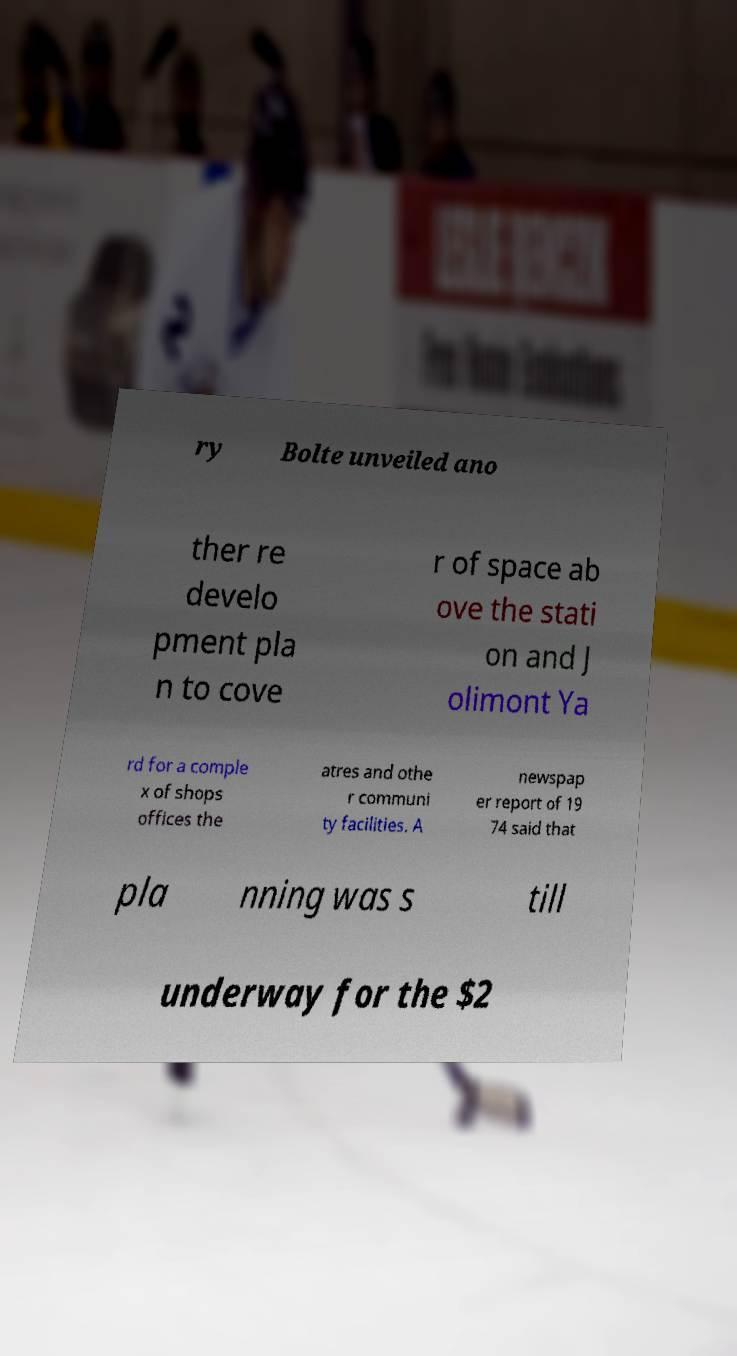There's text embedded in this image that I need extracted. Can you transcribe it verbatim? ry Bolte unveiled ano ther re develo pment pla n to cove r of space ab ove the stati on and J olimont Ya rd for a comple x of shops offices the atres and othe r communi ty facilities. A newspap er report of 19 74 said that pla nning was s till underway for the $2 